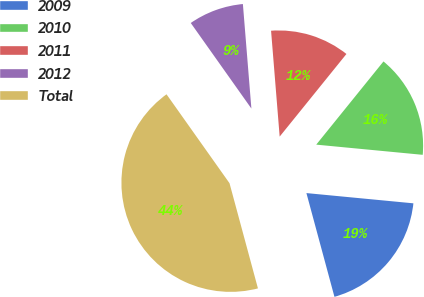<chart> <loc_0><loc_0><loc_500><loc_500><pie_chart><fcel>2009<fcel>2010<fcel>2011<fcel>2012<fcel>Total<nl><fcel>19.28%<fcel>15.7%<fcel>12.11%<fcel>8.52%<fcel>44.39%<nl></chart> 